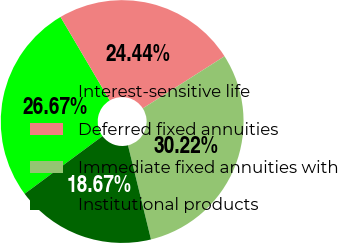<chart> <loc_0><loc_0><loc_500><loc_500><pie_chart><fcel>Interest-sensitive life<fcel>Deferred fixed annuities<fcel>Immediate fixed annuities with<fcel>Institutional products<nl><fcel>26.67%<fcel>24.44%<fcel>30.22%<fcel>18.67%<nl></chart> 